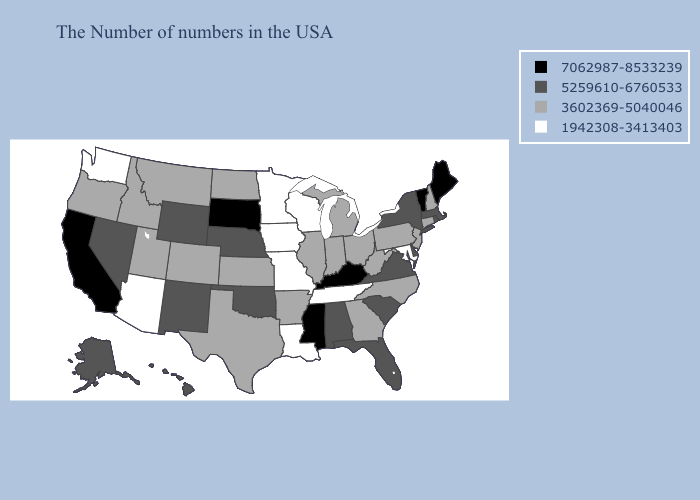What is the value of Alabama?
Concise answer only. 5259610-6760533. Which states hav the highest value in the Northeast?
Give a very brief answer. Maine, Vermont. Name the states that have a value in the range 3602369-5040046?
Be succinct. New Hampshire, Connecticut, New Jersey, Pennsylvania, North Carolina, West Virginia, Ohio, Georgia, Michigan, Indiana, Illinois, Arkansas, Kansas, Texas, North Dakota, Colorado, Utah, Montana, Idaho, Oregon. Name the states that have a value in the range 5259610-6760533?
Be succinct. Massachusetts, Rhode Island, New York, Delaware, Virginia, South Carolina, Florida, Alabama, Nebraska, Oklahoma, Wyoming, New Mexico, Nevada, Alaska, Hawaii. What is the lowest value in the Northeast?
Be succinct. 3602369-5040046. Does Kentucky have the lowest value in the USA?
Answer briefly. No. Does North Dakota have the lowest value in the USA?
Keep it brief. No. Name the states that have a value in the range 5259610-6760533?
Write a very short answer. Massachusetts, Rhode Island, New York, Delaware, Virginia, South Carolina, Florida, Alabama, Nebraska, Oklahoma, Wyoming, New Mexico, Nevada, Alaska, Hawaii. Does Michigan have the lowest value in the MidWest?
Give a very brief answer. No. What is the value of Mississippi?
Answer briefly. 7062987-8533239. Which states hav the highest value in the West?
Be succinct. California. Is the legend a continuous bar?
Keep it brief. No. What is the highest value in the USA?
Give a very brief answer. 7062987-8533239. What is the value of Oregon?
Short answer required. 3602369-5040046. Does Maryland have a higher value than North Carolina?
Give a very brief answer. No. 